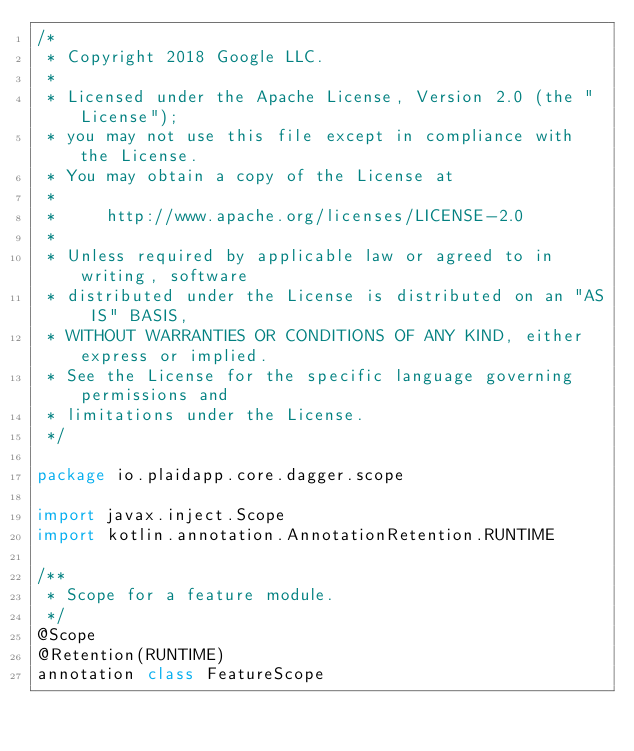<code> <loc_0><loc_0><loc_500><loc_500><_Kotlin_>/*
 * Copyright 2018 Google LLC.
 *
 * Licensed under the Apache License, Version 2.0 (the "License");
 * you may not use this file except in compliance with the License.
 * You may obtain a copy of the License at
 *
 *     http://www.apache.org/licenses/LICENSE-2.0
 *
 * Unless required by applicable law or agreed to in writing, software
 * distributed under the License is distributed on an "AS IS" BASIS,
 * WITHOUT WARRANTIES OR CONDITIONS OF ANY KIND, either express or implied.
 * See the License for the specific language governing permissions and
 * limitations under the License.
 */

package io.plaidapp.core.dagger.scope

import javax.inject.Scope
import kotlin.annotation.AnnotationRetention.RUNTIME

/**
 * Scope for a feature module.
 */
@Scope
@Retention(RUNTIME)
annotation class FeatureScope
</code> 